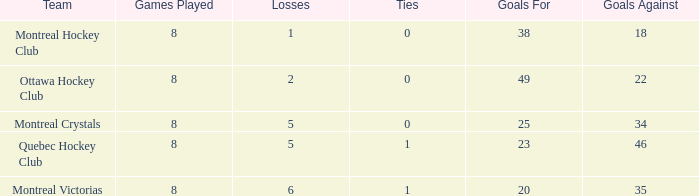What is the highest goals against when the wins is less than 1? None. 